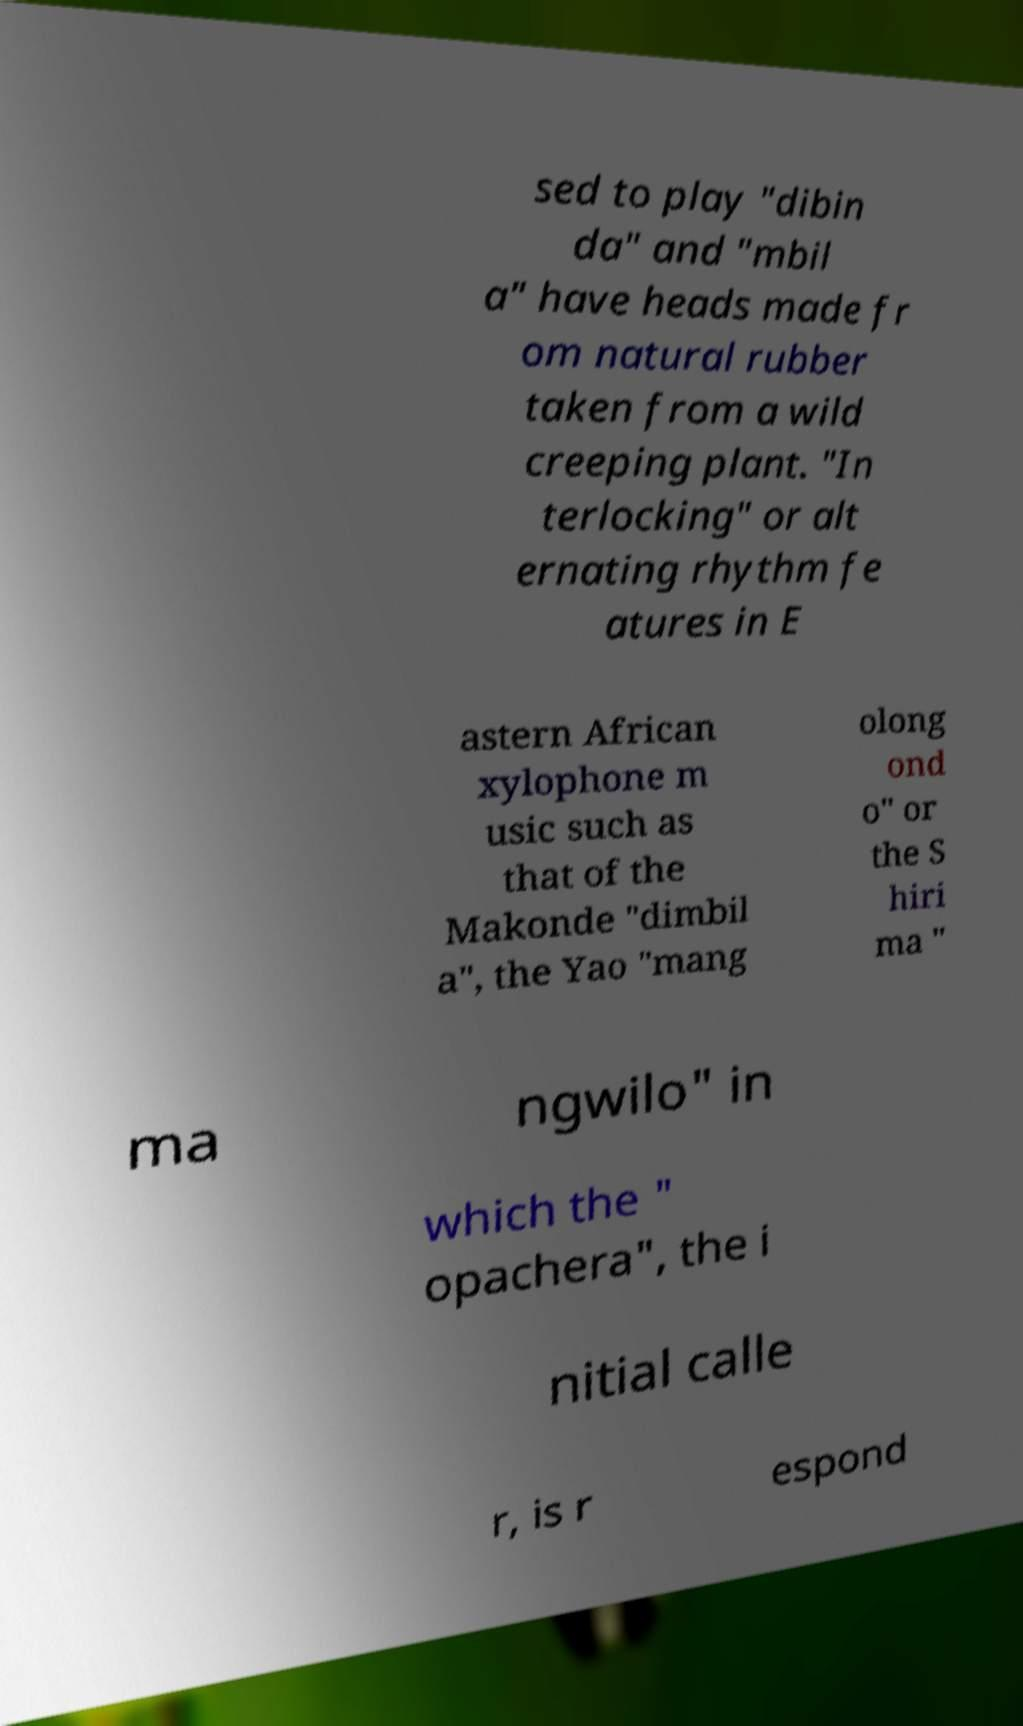Can you read and provide the text displayed in the image?This photo seems to have some interesting text. Can you extract and type it out for me? sed to play "dibin da" and "mbil a" have heads made fr om natural rubber taken from a wild creeping plant. "In terlocking" or alt ernating rhythm fe atures in E astern African xylophone m usic such as that of the Makonde "dimbil a", the Yao "mang olong ond o" or the S hiri ma " ma ngwilo" in which the " opachera", the i nitial calle r, is r espond 